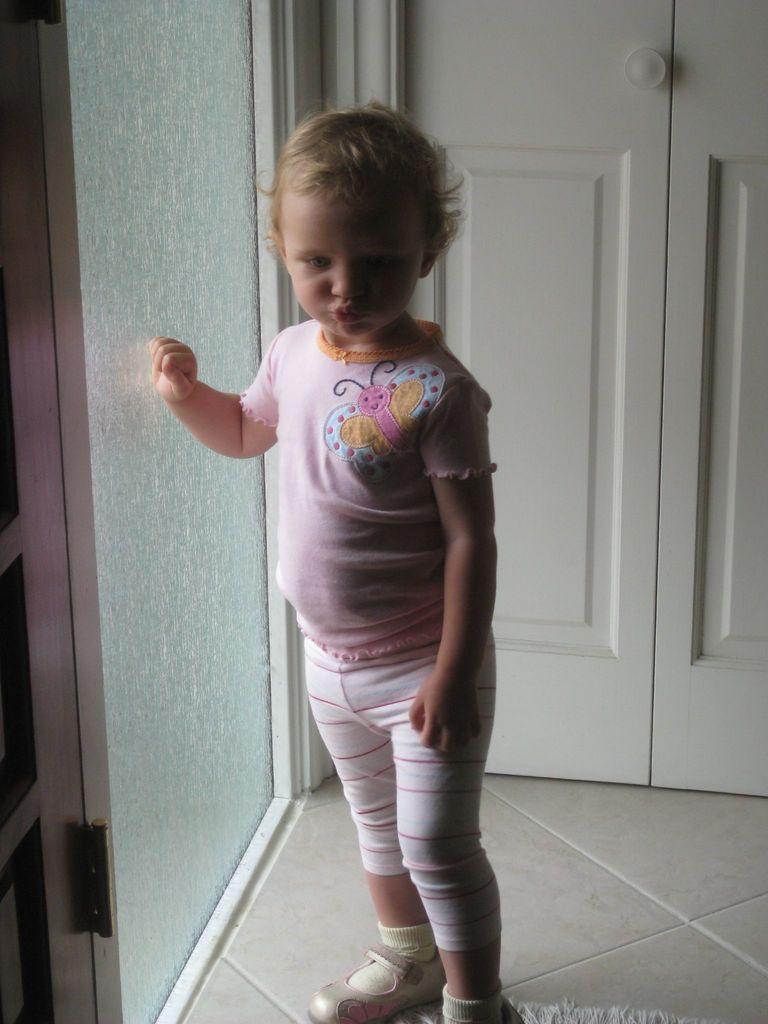How would you summarize this image in a sentence or two? In the picture we can see a child standing on the floor beside the child we can see a glass wall and behind the child we can see a door which is white in color. 